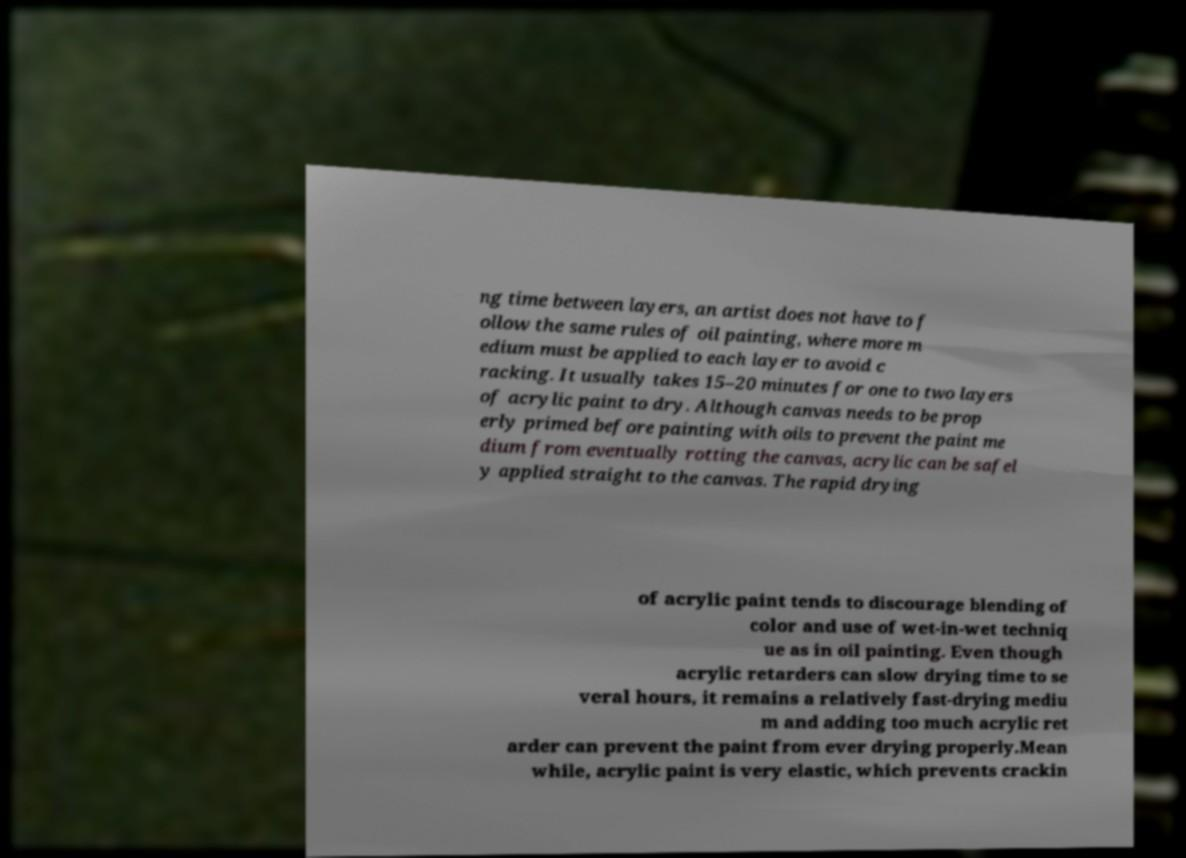What messages or text are displayed in this image? I need them in a readable, typed format. ng time between layers, an artist does not have to f ollow the same rules of oil painting, where more m edium must be applied to each layer to avoid c racking. It usually takes 15–20 minutes for one to two layers of acrylic paint to dry. Although canvas needs to be prop erly primed before painting with oils to prevent the paint me dium from eventually rotting the canvas, acrylic can be safel y applied straight to the canvas. The rapid drying of acrylic paint tends to discourage blending of color and use of wet-in-wet techniq ue as in oil painting. Even though acrylic retarders can slow drying time to se veral hours, it remains a relatively fast-drying mediu m and adding too much acrylic ret arder can prevent the paint from ever drying properly.Mean while, acrylic paint is very elastic, which prevents crackin 